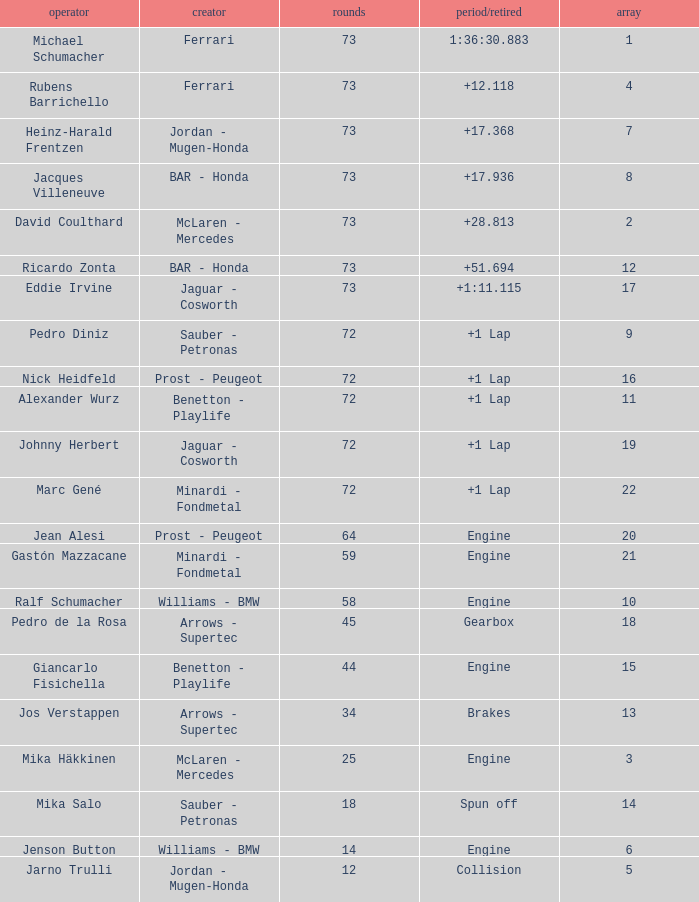How many laps did Jos Verstappen do on Grid 2? 34.0. 